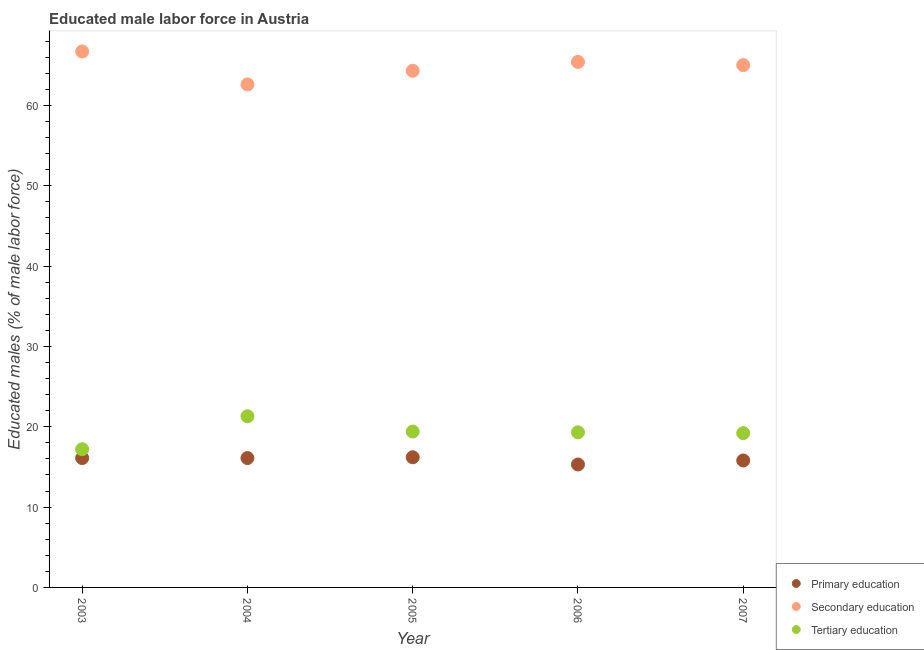How many different coloured dotlines are there?
Keep it short and to the point. 3. What is the percentage of male labor force who received primary education in 2006?
Your answer should be compact. 15.3. Across all years, what is the maximum percentage of male labor force who received primary education?
Keep it short and to the point. 16.2. Across all years, what is the minimum percentage of male labor force who received tertiary education?
Give a very brief answer. 17.2. What is the total percentage of male labor force who received secondary education in the graph?
Offer a terse response. 324. What is the difference between the percentage of male labor force who received primary education in 2003 and that in 2006?
Offer a very short reply. 0.8. What is the difference between the percentage of male labor force who received primary education in 2006 and the percentage of male labor force who received secondary education in 2004?
Provide a succinct answer. -47.3. What is the average percentage of male labor force who received primary education per year?
Offer a terse response. 15.9. In the year 2006, what is the difference between the percentage of male labor force who received secondary education and percentage of male labor force who received tertiary education?
Offer a very short reply. 46.1. In how many years, is the percentage of male labor force who received primary education greater than 60 %?
Offer a very short reply. 0. What is the ratio of the percentage of male labor force who received secondary education in 2004 to that in 2007?
Keep it short and to the point. 0.96. Is the percentage of male labor force who received tertiary education in 2005 less than that in 2006?
Give a very brief answer. No. What is the difference between the highest and the second highest percentage of male labor force who received tertiary education?
Your response must be concise. 1.9. What is the difference between the highest and the lowest percentage of male labor force who received primary education?
Offer a terse response. 0.9. In how many years, is the percentage of male labor force who received primary education greater than the average percentage of male labor force who received primary education taken over all years?
Your answer should be compact. 3. Is the sum of the percentage of male labor force who received primary education in 2005 and 2006 greater than the maximum percentage of male labor force who received secondary education across all years?
Your response must be concise. No. Does the percentage of male labor force who received primary education monotonically increase over the years?
Ensure brevity in your answer.  No. Is the percentage of male labor force who received primary education strictly greater than the percentage of male labor force who received secondary education over the years?
Your answer should be very brief. No. Is the percentage of male labor force who received secondary education strictly less than the percentage of male labor force who received tertiary education over the years?
Your answer should be very brief. No. Are the values on the major ticks of Y-axis written in scientific E-notation?
Ensure brevity in your answer.  No. Does the graph contain any zero values?
Your answer should be very brief. No. Does the graph contain grids?
Provide a succinct answer. No. What is the title of the graph?
Keep it short and to the point. Educated male labor force in Austria. What is the label or title of the Y-axis?
Give a very brief answer. Educated males (% of male labor force). What is the Educated males (% of male labor force) of Primary education in 2003?
Ensure brevity in your answer.  16.1. What is the Educated males (% of male labor force) of Secondary education in 2003?
Ensure brevity in your answer.  66.7. What is the Educated males (% of male labor force) of Tertiary education in 2003?
Your answer should be very brief. 17.2. What is the Educated males (% of male labor force) in Primary education in 2004?
Ensure brevity in your answer.  16.1. What is the Educated males (% of male labor force) of Secondary education in 2004?
Make the answer very short. 62.6. What is the Educated males (% of male labor force) of Tertiary education in 2004?
Your answer should be very brief. 21.3. What is the Educated males (% of male labor force) in Primary education in 2005?
Offer a terse response. 16.2. What is the Educated males (% of male labor force) of Secondary education in 2005?
Your response must be concise. 64.3. What is the Educated males (% of male labor force) of Tertiary education in 2005?
Offer a terse response. 19.4. What is the Educated males (% of male labor force) in Primary education in 2006?
Offer a terse response. 15.3. What is the Educated males (% of male labor force) of Secondary education in 2006?
Make the answer very short. 65.4. What is the Educated males (% of male labor force) of Tertiary education in 2006?
Provide a short and direct response. 19.3. What is the Educated males (% of male labor force) in Primary education in 2007?
Keep it short and to the point. 15.8. What is the Educated males (% of male labor force) of Secondary education in 2007?
Offer a very short reply. 65. What is the Educated males (% of male labor force) of Tertiary education in 2007?
Your answer should be compact. 19.2. Across all years, what is the maximum Educated males (% of male labor force) of Primary education?
Your answer should be compact. 16.2. Across all years, what is the maximum Educated males (% of male labor force) in Secondary education?
Your answer should be compact. 66.7. Across all years, what is the maximum Educated males (% of male labor force) in Tertiary education?
Your answer should be very brief. 21.3. Across all years, what is the minimum Educated males (% of male labor force) in Primary education?
Provide a succinct answer. 15.3. Across all years, what is the minimum Educated males (% of male labor force) of Secondary education?
Keep it short and to the point. 62.6. Across all years, what is the minimum Educated males (% of male labor force) in Tertiary education?
Provide a short and direct response. 17.2. What is the total Educated males (% of male labor force) of Primary education in the graph?
Offer a terse response. 79.5. What is the total Educated males (% of male labor force) of Secondary education in the graph?
Provide a short and direct response. 324. What is the total Educated males (% of male labor force) of Tertiary education in the graph?
Your response must be concise. 96.4. What is the difference between the Educated males (% of male labor force) in Primary education in 2003 and that in 2004?
Your answer should be very brief. 0. What is the difference between the Educated males (% of male labor force) in Secondary education in 2003 and that in 2004?
Make the answer very short. 4.1. What is the difference between the Educated males (% of male labor force) of Secondary education in 2003 and that in 2005?
Your answer should be very brief. 2.4. What is the difference between the Educated males (% of male labor force) of Tertiary education in 2003 and that in 2005?
Provide a succinct answer. -2.2. What is the difference between the Educated males (% of male labor force) of Tertiary education in 2003 and that in 2007?
Ensure brevity in your answer.  -2. What is the difference between the Educated males (% of male labor force) of Primary education in 2004 and that in 2006?
Give a very brief answer. 0.8. What is the difference between the Educated males (% of male labor force) in Tertiary education in 2004 and that in 2006?
Your answer should be very brief. 2. What is the difference between the Educated males (% of male labor force) in Primary education in 2004 and that in 2007?
Provide a short and direct response. 0.3. What is the difference between the Educated males (% of male labor force) in Secondary education in 2004 and that in 2007?
Ensure brevity in your answer.  -2.4. What is the difference between the Educated males (% of male labor force) in Tertiary education in 2004 and that in 2007?
Make the answer very short. 2.1. What is the difference between the Educated males (% of male labor force) in Primary education in 2005 and that in 2006?
Your answer should be compact. 0.9. What is the difference between the Educated males (% of male labor force) of Tertiary education in 2005 and that in 2006?
Provide a succinct answer. 0.1. What is the difference between the Educated males (% of male labor force) of Secondary education in 2005 and that in 2007?
Your response must be concise. -0.7. What is the difference between the Educated males (% of male labor force) of Primary education in 2006 and that in 2007?
Your answer should be compact. -0.5. What is the difference between the Educated males (% of male labor force) of Secondary education in 2006 and that in 2007?
Your answer should be compact. 0.4. What is the difference between the Educated males (% of male labor force) of Tertiary education in 2006 and that in 2007?
Make the answer very short. 0.1. What is the difference between the Educated males (% of male labor force) of Primary education in 2003 and the Educated males (% of male labor force) of Secondary education in 2004?
Offer a very short reply. -46.5. What is the difference between the Educated males (% of male labor force) in Primary education in 2003 and the Educated males (% of male labor force) in Tertiary education in 2004?
Give a very brief answer. -5.2. What is the difference between the Educated males (% of male labor force) in Secondary education in 2003 and the Educated males (% of male labor force) in Tertiary education in 2004?
Provide a succinct answer. 45.4. What is the difference between the Educated males (% of male labor force) in Primary education in 2003 and the Educated males (% of male labor force) in Secondary education in 2005?
Your answer should be compact. -48.2. What is the difference between the Educated males (% of male labor force) in Primary education in 2003 and the Educated males (% of male labor force) in Tertiary education in 2005?
Offer a very short reply. -3.3. What is the difference between the Educated males (% of male labor force) in Secondary education in 2003 and the Educated males (% of male labor force) in Tertiary education in 2005?
Offer a very short reply. 47.3. What is the difference between the Educated males (% of male labor force) of Primary education in 2003 and the Educated males (% of male labor force) of Secondary education in 2006?
Provide a short and direct response. -49.3. What is the difference between the Educated males (% of male labor force) in Primary education in 2003 and the Educated males (% of male labor force) in Tertiary education in 2006?
Your answer should be compact. -3.2. What is the difference between the Educated males (% of male labor force) of Secondary education in 2003 and the Educated males (% of male labor force) of Tertiary education in 2006?
Make the answer very short. 47.4. What is the difference between the Educated males (% of male labor force) in Primary education in 2003 and the Educated males (% of male labor force) in Secondary education in 2007?
Provide a succinct answer. -48.9. What is the difference between the Educated males (% of male labor force) of Primary education in 2003 and the Educated males (% of male labor force) of Tertiary education in 2007?
Your response must be concise. -3.1. What is the difference between the Educated males (% of male labor force) in Secondary education in 2003 and the Educated males (% of male labor force) in Tertiary education in 2007?
Give a very brief answer. 47.5. What is the difference between the Educated males (% of male labor force) in Primary education in 2004 and the Educated males (% of male labor force) in Secondary education in 2005?
Keep it short and to the point. -48.2. What is the difference between the Educated males (% of male labor force) of Secondary education in 2004 and the Educated males (% of male labor force) of Tertiary education in 2005?
Provide a short and direct response. 43.2. What is the difference between the Educated males (% of male labor force) of Primary education in 2004 and the Educated males (% of male labor force) of Secondary education in 2006?
Provide a short and direct response. -49.3. What is the difference between the Educated males (% of male labor force) of Secondary education in 2004 and the Educated males (% of male labor force) of Tertiary education in 2006?
Give a very brief answer. 43.3. What is the difference between the Educated males (% of male labor force) of Primary education in 2004 and the Educated males (% of male labor force) of Secondary education in 2007?
Your answer should be compact. -48.9. What is the difference between the Educated males (% of male labor force) of Secondary education in 2004 and the Educated males (% of male labor force) of Tertiary education in 2007?
Your response must be concise. 43.4. What is the difference between the Educated males (% of male labor force) of Primary education in 2005 and the Educated males (% of male labor force) of Secondary education in 2006?
Ensure brevity in your answer.  -49.2. What is the difference between the Educated males (% of male labor force) in Primary education in 2005 and the Educated males (% of male labor force) in Tertiary education in 2006?
Your answer should be compact. -3.1. What is the difference between the Educated males (% of male labor force) of Secondary education in 2005 and the Educated males (% of male labor force) of Tertiary education in 2006?
Your answer should be compact. 45. What is the difference between the Educated males (% of male labor force) of Primary education in 2005 and the Educated males (% of male labor force) of Secondary education in 2007?
Keep it short and to the point. -48.8. What is the difference between the Educated males (% of male labor force) in Primary education in 2005 and the Educated males (% of male labor force) in Tertiary education in 2007?
Provide a short and direct response. -3. What is the difference between the Educated males (% of male labor force) in Secondary education in 2005 and the Educated males (% of male labor force) in Tertiary education in 2007?
Give a very brief answer. 45.1. What is the difference between the Educated males (% of male labor force) in Primary education in 2006 and the Educated males (% of male labor force) in Secondary education in 2007?
Keep it short and to the point. -49.7. What is the difference between the Educated males (% of male labor force) of Primary education in 2006 and the Educated males (% of male labor force) of Tertiary education in 2007?
Give a very brief answer. -3.9. What is the difference between the Educated males (% of male labor force) of Secondary education in 2006 and the Educated males (% of male labor force) of Tertiary education in 2007?
Your response must be concise. 46.2. What is the average Educated males (% of male labor force) in Primary education per year?
Provide a short and direct response. 15.9. What is the average Educated males (% of male labor force) in Secondary education per year?
Offer a very short reply. 64.8. What is the average Educated males (% of male labor force) of Tertiary education per year?
Provide a short and direct response. 19.28. In the year 2003, what is the difference between the Educated males (% of male labor force) of Primary education and Educated males (% of male labor force) of Secondary education?
Give a very brief answer. -50.6. In the year 2003, what is the difference between the Educated males (% of male labor force) in Secondary education and Educated males (% of male labor force) in Tertiary education?
Give a very brief answer. 49.5. In the year 2004, what is the difference between the Educated males (% of male labor force) of Primary education and Educated males (% of male labor force) of Secondary education?
Provide a short and direct response. -46.5. In the year 2004, what is the difference between the Educated males (% of male labor force) of Primary education and Educated males (% of male labor force) of Tertiary education?
Ensure brevity in your answer.  -5.2. In the year 2004, what is the difference between the Educated males (% of male labor force) in Secondary education and Educated males (% of male labor force) in Tertiary education?
Provide a short and direct response. 41.3. In the year 2005, what is the difference between the Educated males (% of male labor force) in Primary education and Educated males (% of male labor force) in Secondary education?
Provide a short and direct response. -48.1. In the year 2005, what is the difference between the Educated males (% of male labor force) of Primary education and Educated males (% of male labor force) of Tertiary education?
Your answer should be compact. -3.2. In the year 2005, what is the difference between the Educated males (% of male labor force) of Secondary education and Educated males (% of male labor force) of Tertiary education?
Your answer should be compact. 44.9. In the year 2006, what is the difference between the Educated males (% of male labor force) in Primary education and Educated males (% of male labor force) in Secondary education?
Make the answer very short. -50.1. In the year 2006, what is the difference between the Educated males (% of male labor force) in Primary education and Educated males (% of male labor force) in Tertiary education?
Keep it short and to the point. -4. In the year 2006, what is the difference between the Educated males (% of male labor force) in Secondary education and Educated males (% of male labor force) in Tertiary education?
Keep it short and to the point. 46.1. In the year 2007, what is the difference between the Educated males (% of male labor force) of Primary education and Educated males (% of male labor force) of Secondary education?
Provide a succinct answer. -49.2. In the year 2007, what is the difference between the Educated males (% of male labor force) in Secondary education and Educated males (% of male labor force) in Tertiary education?
Give a very brief answer. 45.8. What is the ratio of the Educated males (% of male labor force) in Secondary education in 2003 to that in 2004?
Make the answer very short. 1.07. What is the ratio of the Educated males (% of male labor force) of Tertiary education in 2003 to that in 2004?
Make the answer very short. 0.81. What is the ratio of the Educated males (% of male labor force) in Secondary education in 2003 to that in 2005?
Make the answer very short. 1.04. What is the ratio of the Educated males (% of male labor force) in Tertiary education in 2003 to that in 2005?
Your response must be concise. 0.89. What is the ratio of the Educated males (% of male labor force) in Primary education in 2003 to that in 2006?
Provide a succinct answer. 1.05. What is the ratio of the Educated males (% of male labor force) in Secondary education in 2003 to that in 2006?
Provide a short and direct response. 1.02. What is the ratio of the Educated males (% of male labor force) of Tertiary education in 2003 to that in 2006?
Ensure brevity in your answer.  0.89. What is the ratio of the Educated males (% of male labor force) of Secondary education in 2003 to that in 2007?
Offer a very short reply. 1.03. What is the ratio of the Educated males (% of male labor force) in Tertiary education in 2003 to that in 2007?
Offer a terse response. 0.9. What is the ratio of the Educated males (% of male labor force) in Secondary education in 2004 to that in 2005?
Offer a terse response. 0.97. What is the ratio of the Educated males (% of male labor force) in Tertiary education in 2004 to that in 2005?
Make the answer very short. 1.1. What is the ratio of the Educated males (% of male labor force) in Primary education in 2004 to that in 2006?
Give a very brief answer. 1.05. What is the ratio of the Educated males (% of male labor force) of Secondary education in 2004 to that in 2006?
Your response must be concise. 0.96. What is the ratio of the Educated males (% of male labor force) in Tertiary education in 2004 to that in 2006?
Make the answer very short. 1.1. What is the ratio of the Educated males (% of male labor force) of Primary education in 2004 to that in 2007?
Ensure brevity in your answer.  1.02. What is the ratio of the Educated males (% of male labor force) of Secondary education in 2004 to that in 2007?
Your response must be concise. 0.96. What is the ratio of the Educated males (% of male labor force) in Tertiary education in 2004 to that in 2007?
Your answer should be very brief. 1.11. What is the ratio of the Educated males (% of male labor force) of Primary education in 2005 to that in 2006?
Offer a terse response. 1.06. What is the ratio of the Educated males (% of male labor force) in Secondary education in 2005 to that in 2006?
Your response must be concise. 0.98. What is the ratio of the Educated males (% of male labor force) of Primary education in 2005 to that in 2007?
Your answer should be compact. 1.03. What is the ratio of the Educated males (% of male labor force) in Tertiary education in 2005 to that in 2007?
Make the answer very short. 1.01. What is the ratio of the Educated males (% of male labor force) in Primary education in 2006 to that in 2007?
Your response must be concise. 0.97. What is the ratio of the Educated males (% of male labor force) in Tertiary education in 2006 to that in 2007?
Make the answer very short. 1.01. What is the difference between the highest and the second highest Educated males (% of male labor force) of Primary education?
Make the answer very short. 0.1. What is the difference between the highest and the second highest Educated males (% of male labor force) in Tertiary education?
Provide a short and direct response. 1.9. What is the difference between the highest and the lowest Educated males (% of male labor force) in Primary education?
Your response must be concise. 0.9. 